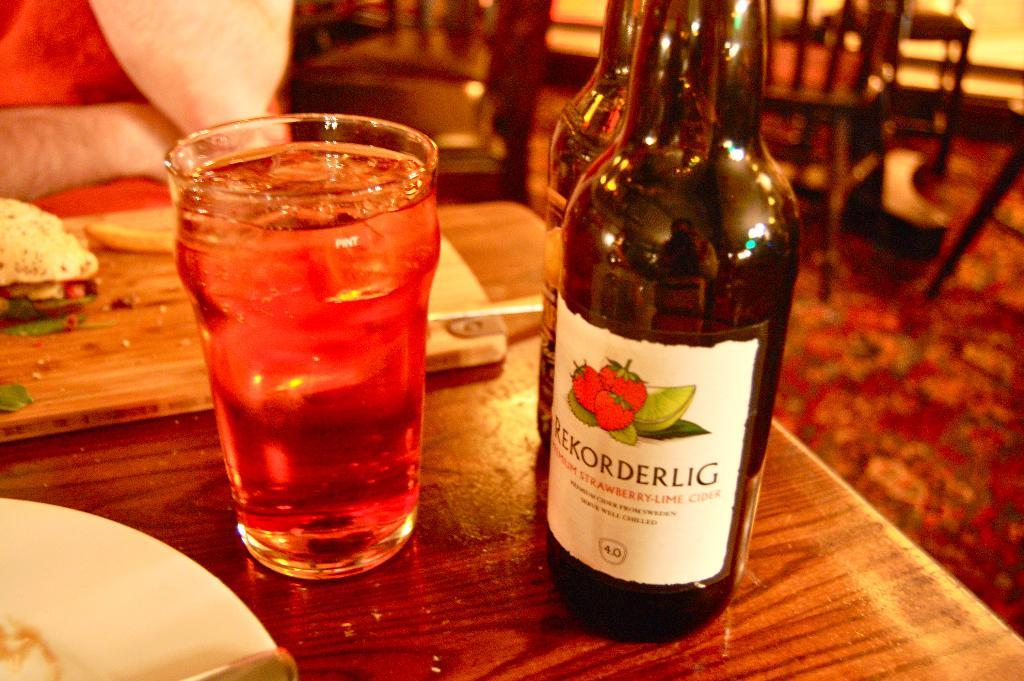<image>
Present a compact description of the photo's key features. a gull glass and bottle of Rekorderlig on a restaurant table 